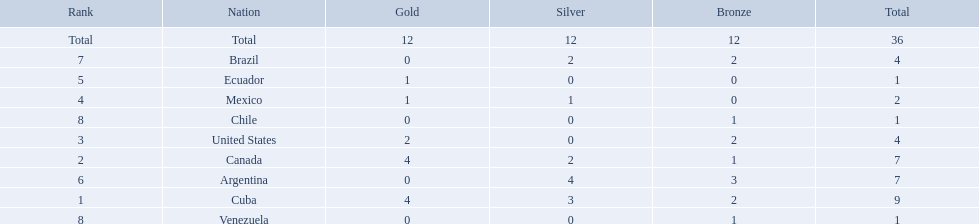Which nations participated? Cuba, Canada, United States, Mexico, Ecuador, Argentina, Brazil, Chile, Venezuela. Which nations won gold? Cuba, Canada, United States, Mexico, Ecuador. Which nations did not win silver? United States, Ecuador, Chile, Venezuela. Out of those countries previously listed, which nation won gold? United States. 